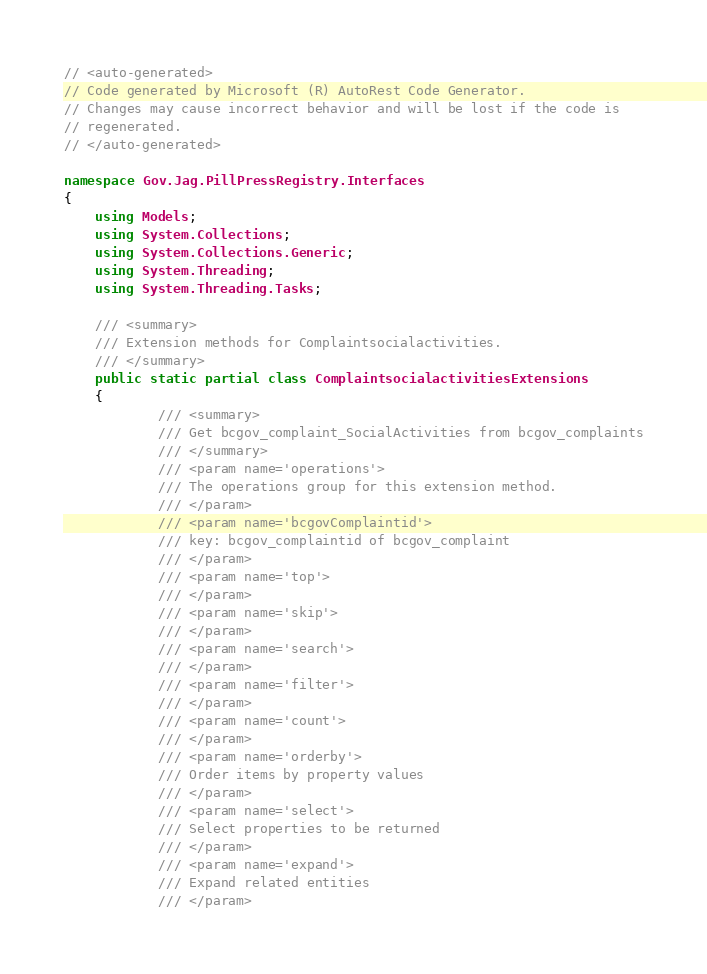<code> <loc_0><loc_0><loc_500><loc_500><_C#_>// <auto-generated>
// Code generated by Microsoft (R) AutoRest Code Generator.
// Changes may cause incorrect behavior and will be lost if the code is
// regenerated.
// </auto-generated>

namespace Gov.Jag.PillPressRegistry.Interfaces
{
    using Models;
    using System.Collections;
    using System.Collections.Generic;
    using System.Threading;
    using System.Threading.Tasks;

    /// <summary>
    /// Extension methods for Complaintsocialactivities.
    /// </summary>
    public static partial class ComplaintsocialactivitiesExtensions
    {
            /// <summary>
            /// Get bcgov_complaint_SocialActivities from bcgov_complaints
            /// </summary>
            /// <param name='operations'>
            /// The operations group for this extension method.
            /// </param>
            /// <param name='bcgovComplaintid'>
            /// key: bcgov_complaintid of bcgov_complaint
            /// </param>
            /// <param name='top'>
            /// </param>
            /// <param name='skip'>
            /// </param>
            /// <param name='search'>
            /// </param>
            /// <param name='filter'>
            /// </param>
            /// <param name='count'>
            /// </param>
            /// <param name='orderby'>
            /// Order items by property values
            /// </param>
            /// <param name='select'>
            /// Select properties to be returned
            /// </param>
            /// <param name='expand'>
            /// Expand related entities
            /// </param></code> 